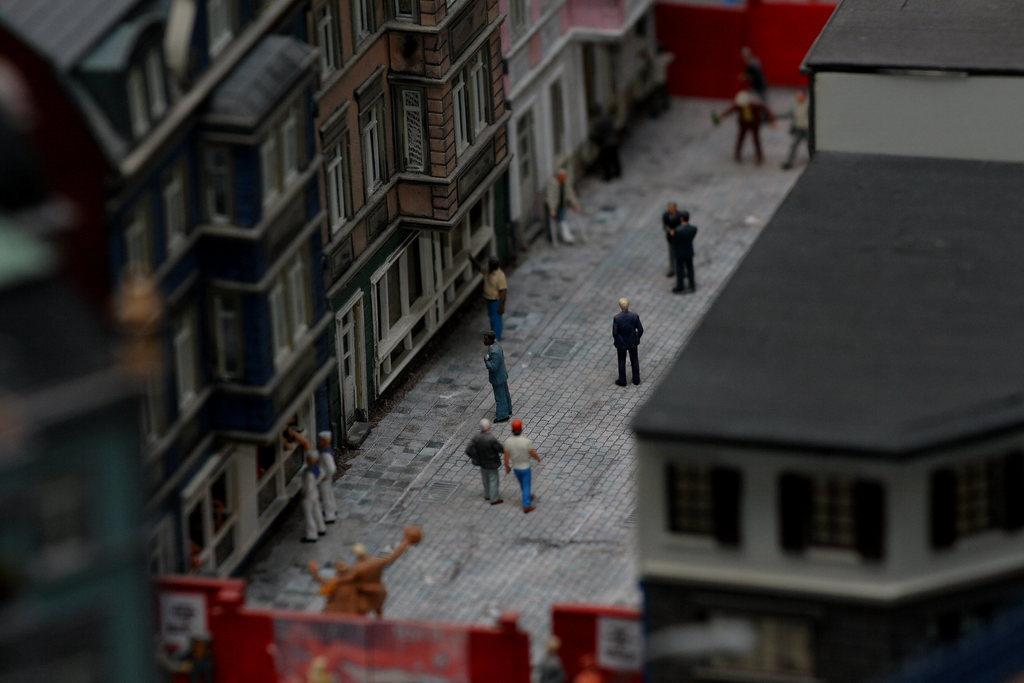How would you summarize this image in a sentence or two? This is an architecture. In this we can see the buildings, toy of persons, road, wall and gates. 